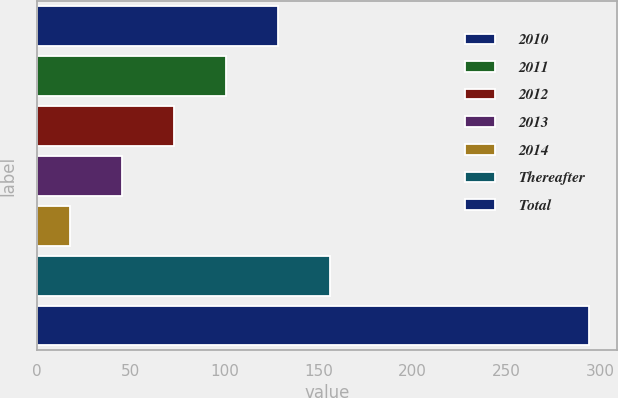Convert chart. <chart><loc_0><loc_0><loc_500><loc_500><bar_chart><fcel>2010<fcel>2011<fcel>2012<fcel>2013<fcel>2014<fcel>Thereafter<fcel>Total<nl><fcel>128.4<fcel>100.8<fcel>73.2<fcel>45.6<fcel>18<fcel>156<fcel>294<nl></chart> 